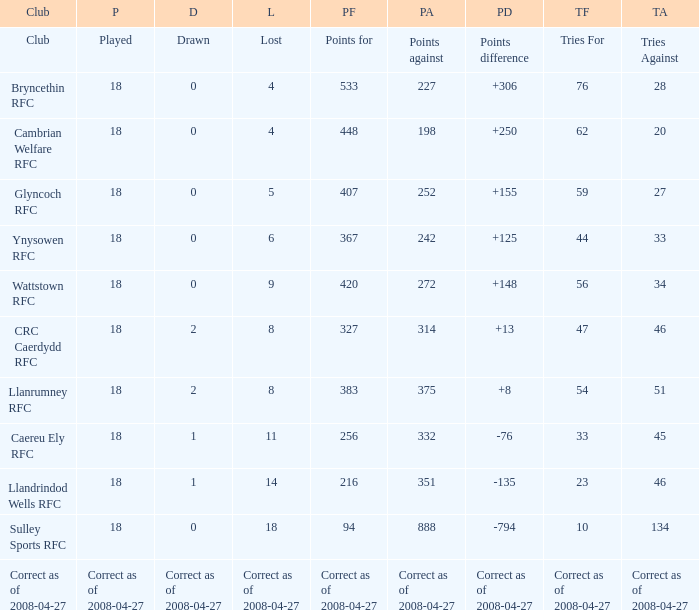What is the value of the item "Points" when the value of the item "Points against" is 272? 420.0. 